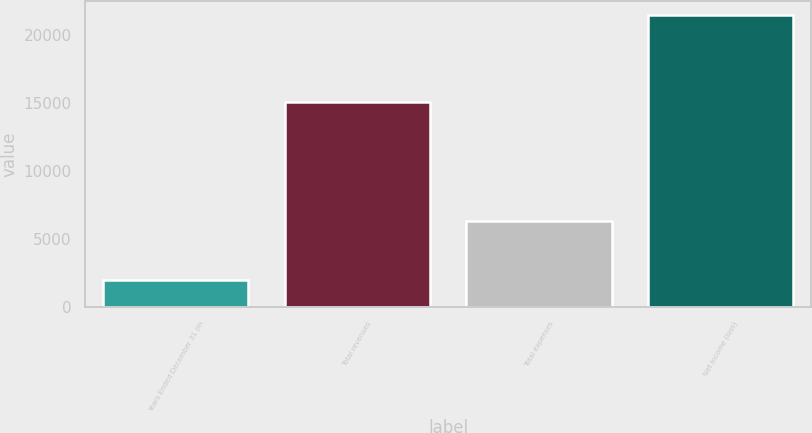Convert chart. <chart><loc_0><loc_0><loc_500><loc_500><bar_chart><fcel>Years Ended December 31 (in<fcel>Total revenues<fcel>Total expenses<fcel>Net income (loss)<nl><fcel>2009<fcel>15082<fcel>6384<fcel>21466<nl></chart> 